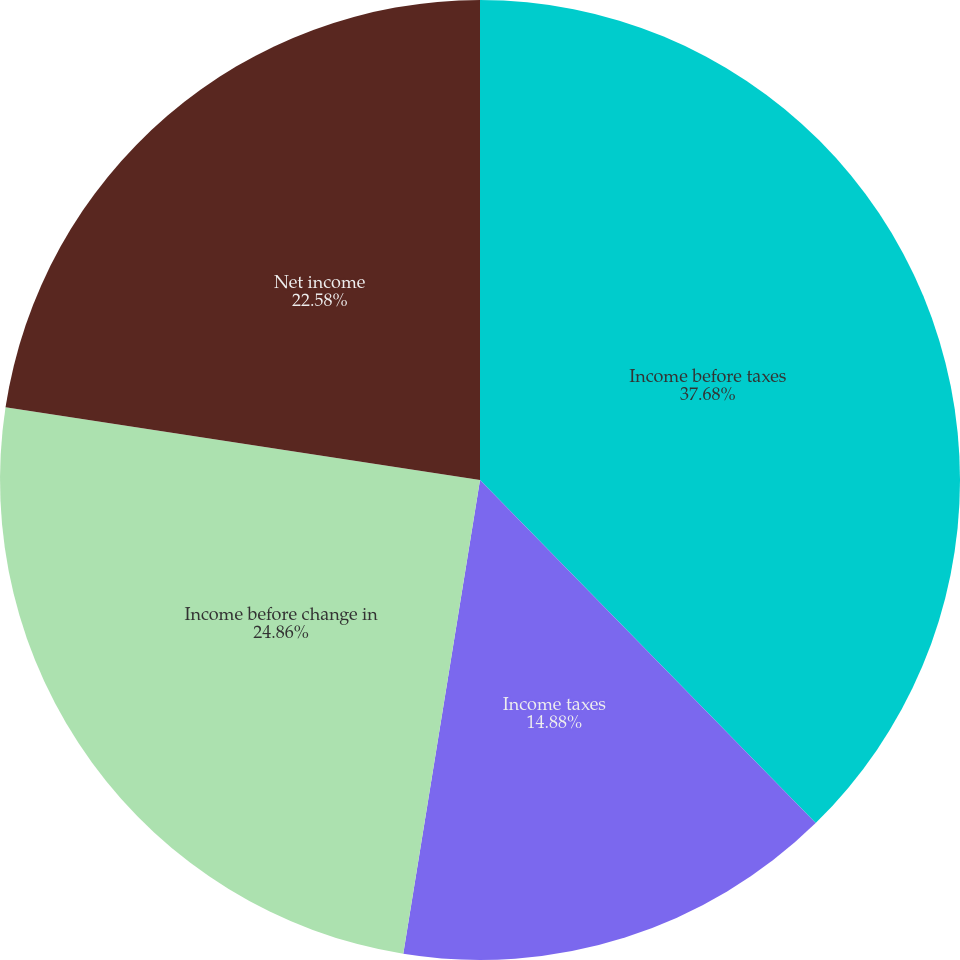<chart> <loc_0><loc_0><loc_500><loc_500><pie_chart><fcel>Income before taxes<fcel>Income taxes<fcel>Income before change in<fcel>Net income<nl><fcel>37.67%<fcel>14.88%<fcel>24.86%<fcel>22.58%<nl></chart> 